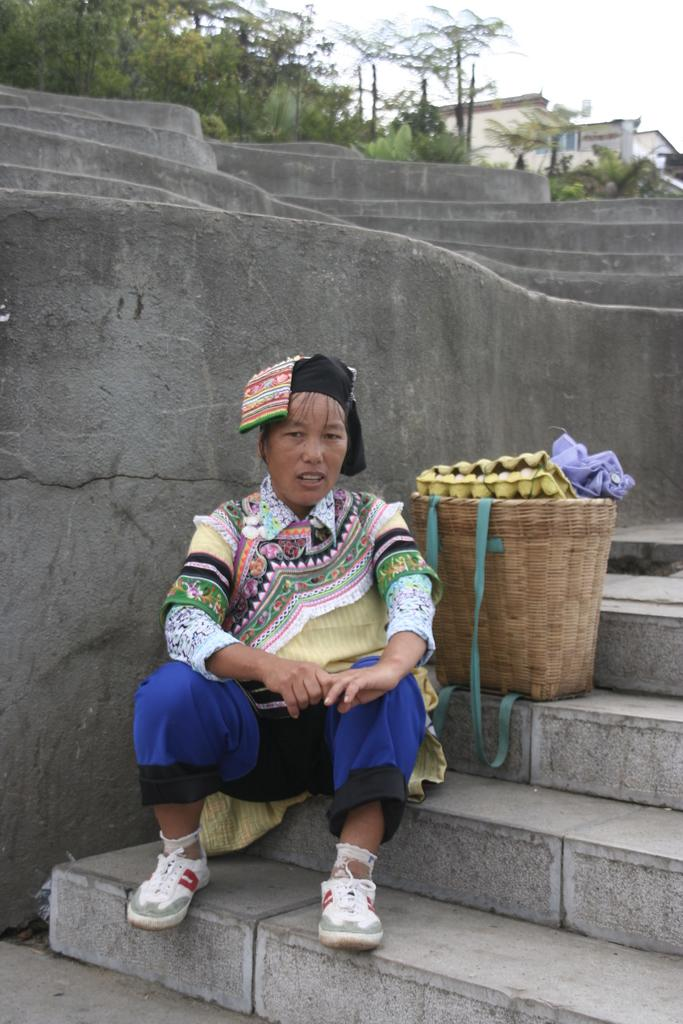Who is the main subject in the front of the image? There is a woman in the front of the image. What is located next to the woman in the front of the image? There is a basket in the front of the image. What else can be seen in the front of the image besides the woman and the basket? There are things in the front of the image. What can be seen in the background of the image? There are trees, buildings, and sky visible in the background of the image. Are there any architectural features in the background? Yes, there are steps in the background of the image. What type of voice can be heard coming from the woman in the image? There is no voice present in the image, as it is a still photograph and does not contain any audio. Can you see any pins or stitches on the woman's clothing in the image? There is no mention of pins or stitches on the woman's clothing in the provided facts, so it cannot be determined from the image. 